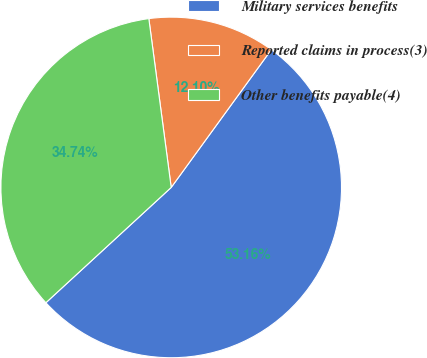Convert chart to OTSL. <chart><loc_0><loc_0><loc_500><loc_500><pie_chart><fcel>Military services benefits<fcel>Reported claims in process(3)<fcel>Other benefits payable(4)<nl><fcel>53.16%<fcel>12.1%<fcel>34.74%<nl></chart> 